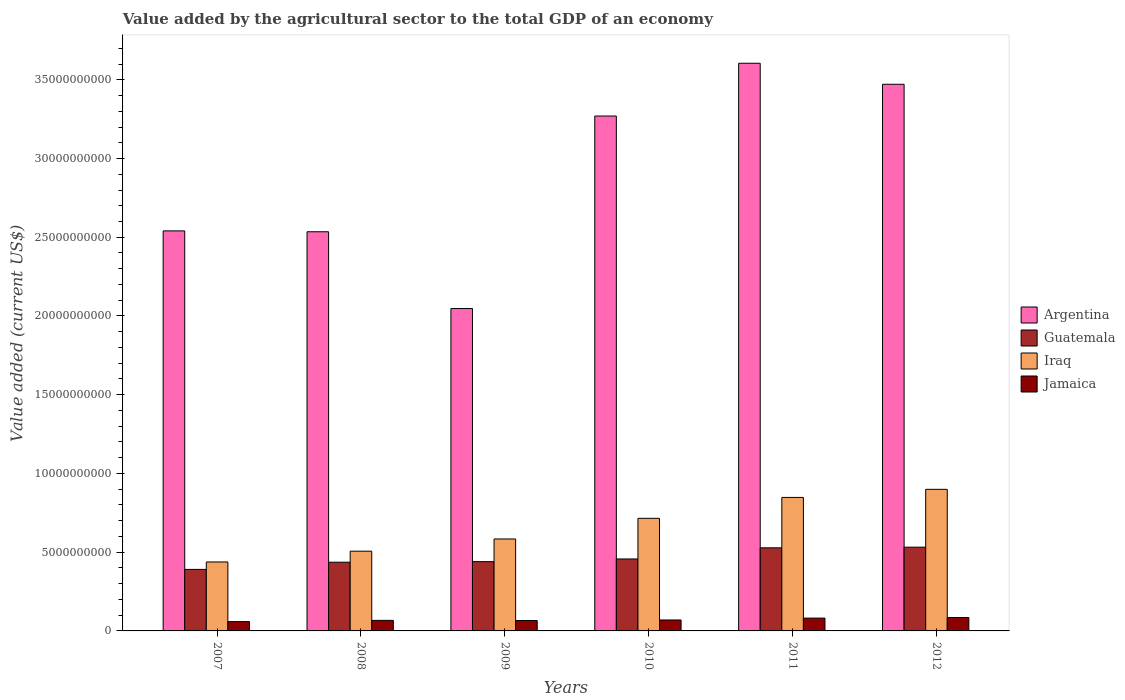How many different coloured bars are there?
Give a very brief answer. 4. How many groups of bars are there?
Give a very brief answer. 6. Are the number of bars on each tick of the X-axis equal?
Keep it short and to the point. Yes. How many bars are there on the 2nd tick from the right?
Your answer should be compact. 4. What is the label of the 5th group of bars from the left?
Ensure brevity in your answer.  2011. What is the value added by the agricultural sector to the total GDP in Iraq in 2008?
Offer a very short reply. 5.06e+09. Across all years, what is the maximum value added by the agricultural sector to the total GDP in Argentina?
Provide a short and direct response. 3.60e+1. Across all years, what is the minimum value added by the agricultural sector to the total GDP in Iraq?
Offer a very short reply. 4.38e+09. In which year was the value added by the agricultural sector to the total GDP in Argentina maximum?
Your response must be concise. 2011. In which year was the value added by the agricultural sector to the total GDP in Iraq minimum?
Your answer should be very brief. 2007. What is the total value added by the agricultural sector to the total GDP in Argentina in the graph?
Offer a terse response. 1.75e+11. What is the difference between the value added by the agricultural sector to the total GDP in Argentina in 2009 and that in 2010?
Your answer should be compact. -1.22e+1. What is the difference between the value added by the agricultural sector to the total GDP in Argentina in 2008 and the value added by the agricultural sector to the total GDP in Iraq in 2007?
Your response must be concise. 2.10e+1. What is the average value added by the agricultural sector to the total GDP in Argentina per year?
Keep it short and to the point. 2.91e+1. In the year 2012, what is the difference between the value added by the agricultural sector to the total GDP in Jamaica and value added by the agricultural sector to the total GDP in Iraq?
Make the answer very short. -8.14e+09. What is the ratio of the value added by the agricultural sector to the total GDP in Iraq in 2008 to that in 2012?
Ensure brevity in your answer.  0.56. What is the difference between the highest and the second highest value added by the agricultural sector to the total GDP in Argentina?
Your answer should be very brief. 1.33e+09. What is the difference between the highest and the lowest value added by the agricultural sector to the total GDP in Jamaica?
Give a very brief answer. 2.60e+08. In how many years, is the value added by the agricultural sector to the total GDP in Jamaica greater than the average value added by the agricultural sector to the total GDP in Jamaica taken over all years?
Ensure brevity in your answer.  2. Is the sum of the value added by the agricultural sector to the total GDP in Argentina in 2009 and 2011 greater than the maximum value added by the agricultural sector to the total GDP in Guatemala across all years?
Make the answer very short. Yes. What does the 2nd bar from the left in 2012 represents?
Offer a terse response. Guatemala. What does the 1st bar from the right in 2009 represents?
Give a very brief answer. Jamaica. Are all the bars in the graph horizontal?
Provide a short and direct response. No. What is the difference between two consecutive major ticks on the Y-axis?
Provide a short and direct response. 5.00e+09. Are the values on the major ticks of Y-axis written in scientific E-notation?
Give a very brief answer. No. Does the graph contain any zero values?
Your answer should be compact. No. Does the graph contain grids?
Ensure brevity in your answer.  No. Where does the legend appear in the graph?
Keep it short and to the point. Center right. What is the title of the graph?
Ensure brevity in your answer.  Value added by the agricultural sector to the total GDP of an economy. Does "Somalia" appear as one of the legend labels in the graph?
Keep it short and to the point. No. What is the label or title of the X-axis?
Offer a terse response. Years. What is the label or title of the Y-axis?
Your answer should be compact. Value added (current US$). What is the Value added (current US$) in Argentina in 2007?
Your response must be concise. 2.54e+1. What is the Value added (current US$) in Guatemala in 2007?
Provide a short and direct response. 3.91e+09. What is the Value added (current US$) in Iraq in 2007?
Your answer should be very brief. 4.38e+09. What is the Value added (current US$) in Jamaica in 2007?
Keep it short and to the point. 5.92e+08. What is the Value added (current US$) of Argentina in 2008?
Give a very brief answer. 2.53e+1. What is the Value added (current US$) of Guatemala in 2008?
Offer a terse response. 4.36e+09. What is the Value added (current US$) in Iraq in 2008?
Provide a succinct answer. 5.06e+09. What is the Value added (current US$) of Jamaica in 2008?
Your answer should be compact. 6.70e+08. What is the Value added (current US$) of Argentina in 2009?
Offer a terse response. 2.05e+1. What is the Value added (current US$) of Guatemala in 2009?
Provide a short and direct response. 4.40e+09. What is the Value added (current US$) of Iraq in 2009?
Your answer should be compact. 5.84e+09. What is the Value added (current US$) of Jamaica in 2009?
Provide a succinct answer. 6.59e+08. What is the Value added (current US$) in Argentina in 2010?
Offer a terse response. 3.27e+1. What is the Value added (current US$) of Guatemala in 2010?
Ensure brevity in your answer.  4.57e+09. What is the Value added (current US$) of Iraq in 2010?
Your answer should be compact. 7.15e+09. What is the Value added (current US$) of Jamaica in 2010?
Your response must be concise. 6.95e+08. What is the Value added (current US$) of Argentina in 2011?
Keep it short and to the point. 3.60e+1. What is the Value added (current US$) in Guatemala in 2011?
Make the answer very short. 5.28e+09. What is the Value added (current US$) of Iraq in 2011?
Provide a short and direct response. 8.48e+09. What is the Value added (current US$) in Jamaica in 2011?
Offer a terse response. 8.14e+08. What is the Value added (current US$) of Argentina in 2012?
Ensure brevity in your answer.  3.47e+1. What is the Value added (current US$) of Guatemala in 2012?
Your answer should be compact. 5.32e+09. What is the Value added (current US$) of Iraq in 2012?
Ensure brevity in your answer.  8.99e+09. What is the Value added (current US$) in Jamaica in 2012?
Offer a very short reply. 8.53e+08. Across all years, what is the maximum Value added (current US$) of Argentina?
Your answer should be compact. 3.60e+1. Across all years, what is the maximum Value added (current US$) of Guatemala?
Your answer should be compact. 5.32e+09. Across all years, what is the maximum Value added (current US$) in Iraq?
Make the answer very short. 8.99e+09. Across all years, what is the maximum Value added (current US$) in Jamaica?
Give a very brief answer. 8.53e+08. Across all years, what is the minimum Value added (current US$) of Argentina?
Provide a succinct answer. 2.05e+1. Across all years, what is the minimum Value added (current US$) of Guatemala?
Offer a very short reply. 3.91e+09. Across all years, what is the minimum Value added (current US$) of Iraq?
Provide a short and direct response. 4.38e+09. Across all years, what is the minimum Value added (current US$) in Jamaica?
Make the answer very short. 5.92e+08. What is the total Value added (current US$) of Argentina in the graph?
Your response must be concise. 1.75e+11. What is the total Value added (current US$) in Guatemala in the graph?
Your answer should be very brief. 2.78e+1. What is the total Value added (current US$) of Iraq in the graph?
Keep it short and to the point. 3.99e+1. What is the total Value added (current US$) of Jamaica in the graph?
Ensure brevity in your answer.  4.28e+09. What is the difference between the Value added (current US$) in Argentina in 2007 and that in 2008?
Give a very brief answer. 5.56e+07. What is the difference between the Value added (current US$) in Guatemala in 2007 and that in 2008?
Your answer should be very brief. -4.57e+08. What is the difference between the Value added (current US$) in Iraq in 2007 and that in 2008?
Offer a very short reply. -6.85e+08. What is the difference between the Value added (current US$) in Jamaica in 2007 and that in 2008?
Your answer should be compact. -7.80e+07. What is the difference between the Value added (current US$) in Argentina in 2007 and that in 2009?
Your answer should be very brief. 4.93e+09. What is the difference between the Value added (current US$) of Guatemala in 2007 and that in 2009?
Provide a short and direct response. -4.92e+08. What is the difference between the Value added (current US$) of Iraq in 2007 and that in 2009?
Your answer should be compact. -1.46e+09. What is the difference between the Value added (current US$) in Jamaica in 2007 and that in 2009?
Your response must be concise. -6.66e+07. What is the difference between the Value added (current US$) of Argentina in 2007 and that in 2010?
Your answer should be very brief. -7.29e+09. What is the difference between the Value added (current US$) of Guatemala in 2007 and that in 2010?
Your answer should be very brief. -6.63e+08. What is the difference between the Value added (current US$) in Iraq in 2007 and that in 2010?
Offer a very short reply. -2.77e+09. What is the difference between the Value added (current US$) of Jamaica in 2007 and that in 2010?
Your answer should be very brief. -1.03e+08. What is the difference between the Value added (current US$) of Argentina in 2007 and that in 2011?
Ensure brevity in your answer.  -1.06e+1. What is the difference between the Value added (current US$) in Guatemala in 2007 and that in 2011?
Offer a very short reply. -1.37e+09. What is the difference between the Value added (current US$) of Iraq in 2007 and that in 2011?
Your response must be concise. -4.10e+09. What is the difference between the Value added (current US$) of Jamaica in 2007 and that in 2011?
Your response must be concise. -2.22e+08. What is the difference between the Value added (current US$) of Argentina in 2007 and that in 2012?
Your answer should be compact. -9.31e+09. What is the difference between the Value added (current US$) of Guatemala in 2007 and that in 2012?
Offer a terse response. -1.41e+09. What is the difference between the Value added (current US$) of Iraq in 2007 and that in 2012?
Your answer should be very brief. -4.61e+09. What is the difference between the Value added (current US$) of Jamaica in 2007 and that in 2012?
Provide a succinct answer. -2.60e+08. What is the difference between the Value added (current US$) of Argentina in 2008 and that in 2009?
Your response must be concise. 4.88e+09. What is the difference between the Value added (current US$) in Guatemala in 2008 and that in 2009?
Offer a terse response. -3.50e+07. What is the difference between the Value added (current US$) in Iraq in 2008 and that in 2009?
Make the answer very short. -7.76e+08. What is the difference between the Value added (current US$) of Jamaica in 2008 and that in 2009?
Offer a terse response. 1.13e+07. What is the difference between the Value added (current US$) of Argentina in 2008 and that in 2010?
Offer a terse response. -7.35e+09. What is the difference between the Value added (current US$) in Guatemala in 2008 and that in 2010?
Your answer should be very brief. -2.06e+08. What is the difference between the Value added (current US$) of Iraq in 2008 and that in 2010?
Ensure brevity in your answer.  -2.09e+09. What is the difference between the Value added (current US$) of Jamaica in 2008 and that in 2010?
Provide a succinct answer. -2.50e+07. What is the difference between the Value added (current US$) in Argentina in 2008 and that in 2011?
Provide a succinct answer. -1.07e+1. What is the difference between the Value added (current US$) in Guatemala in 2008 and that in 2011?
Give a very brief answer. -9.14e+08. What is the difference between the Value added (current US$) of Iraq in 2008 and that in 2011?
Provide a succinct answer. -3.41e+09. What is the difference between the Value added (current US$) of Jamaica in 2008 and that in 2011?
Your answer should be compact. -1.44e+08. What is the difference between the Value added (current US$) of Argentina in 2008 and that in 2012?
Keep it short and to the point. -9.37e+09. What is the difference between the Value added (current US$) of Guatemala in 2008 and that in 2012?
Offer a very short reply. -9.54e+08. What is the difference between the Value added (current US$) of Iraq in 2008 and that in 2012?
Offer a very short reply. -3.93e+09. What is the difference between the Value added (current US$) of Jamaica in 2008 and that in 2012?
Make the answer very short. -1.82e+08. What is the difference between the Value added (current US$) in Argentina in 2009 and that in 2010?
Your response must be concise. -1.22e+1. What is the difference between the Value added (current US$) of Guatemala in 2009 and that in 2010?
Make the answer very short. -1.71e+08. What is the difference between the Value added (current US$) of Iraq in 2009 and that in 2010?
Keep it short and to the point. -1.31e+09. What is the difference between the Value added (current US$) in Jamaica in 2009 and that in 2010?
Ensure brevity in your answer.  -3.63e+07. What is the difference between the Value added (current US$) in Argentina in 2009 and that in 2011?
Your answer should be compact. -1.56e+1. What is the difference between the Value added (current US$) of Guatemala in 2009 and that in 2011?
Give a very brief answer. -8.79e+08. What is the difference between the Value added (current US$) in Iraq in 2009 and that in 2011?
Make the answer very short. -2.64e+09. What is the difference between the Value added (current US$) of Jamaica in 2009 and that in 2011?
Give a very brief answer. -1.55e+08. What is the difference between the Value added (current US$) in Argentina in 2009 and that in 2012?
Give a very brief answer. -1.42e+1. What is the difference between the Value added (current US$) of Guatemala in 2009 and that in 2012?
Your answer should be compact. -9.19e+08. What is the difference between the Value added (current US$) in Iraq in 2009 and that in 2012?
Offer a very short reply. -3.15e+09. What is the difference between the Value added (current US$) in Jamaica in 2009 and that in 2012?
Give a very brief answer. -1.94e+08. What is the difference between the Value added (current US$) of Argentina in 2010 and that in 2011?
Offer a terse response. -3.35e+09. What is the difference between the Value added (current US$) of Guatemala in 2010 and that in 2011?
Offer a terse response. -7.08e+08. What is the difference between the Value added (current US$) in Iraq in 2010 and that in 2011?
Provide a short and direct response. -1.33e+09. What is the difference between the Value added (current US$) of Jamaica in 2010 and that in 2011?
Your response must be concise. -1.19e+08. What is the difference between the Value added (current US$) of Argentina in 2010 and that in 2012?
Offer a very short reply. -2.02e+09. What is the difference between the Value added (current US$) in Guatemala in 2010 and that in 2012?
Your response must be concise. -7.48e+08. What is the difference between the Value added (current US$) of Iraq in 2010 and that in 2012?
Provide a short and direct response. -1.84e+09. What is the difference between the Value added (current US$) of Jamaica in 2010 and that in 2012?
Give a very brief answer. -1.57e+08. What is the difference between the Value added (current US$) in Argentina in 2011 and that in 2012?
Offer a very short reply. 1.33e+09. What is the difference between the Value added (current US$) in Guatemala in 2011 and that in 2012?
Provide a succinct answer. -4.02e+07. What is the difference between the Value added (current US$) of Iraq in 2011 and that in 2012?
Your response must be concise. -5.14e+08. What is the difference between the Value added (current US$) in Jamaica in 2011 and that in 2012?
Offer a very short reply. -3.84e+07. What is the difference between the Value added (current US$) of Argentina in 2007 and the Value added (current US$) of Guatemala in 2008?
Offer a very short reply. 2.10e+1. What is the difference between the Value added (current US$) of Argentina in 2007 and the Value added (current US$) of Iraq in 2008?
Keep it short and to the point. 2.03e+1. What is the difference between the Value added (current US$) of Argentina in 2007 and the Value added (current US$) of Jamaica in 2008?
Provide a short and direct response. 2.47e+1. What is the difference between the Value added (current US$) in Guatemala in 2007 and the Value added (current US$) in Iraq in 2008?
Offer a terse response. -1.16e+09. What is the difference between the Value added (current US$) in Guatemala in 2007 and the Value added (current US$) in Jamaica in 2008?
Keep it short and to the point. 3.24e+09. What is the difference between the Value added (current US$) in Iraq in 2007 and the Value added (current US$) in Jamaica in 2008?
Offer a terse response. 3.71e+09. What is the difference between the Value added (current US$) in Argentina in 2007 and the Value added (current US$) in Guatemala in 2009?
Your answer should be compact. 2.10e+1. What is the difference between the Value added (current US$) of Argentina in 2007 and the Value added (current US$) of Iraq in 2009?
Offer a terse response. 1.96e+1. What is the difference between the Value added (current US$) of Argentina in 2007 and the Value added (current US$) of Jamaica in 2009?
Give a very brief answer. 2.47e+1. What is the difference between the Value added (current US$) in Guatemala in 2007 and the Value added (current US$) in Iraq in 2009?
Give a very brief answer. -1.93e+09. What is the difference between the Value added (current US$) of Guatemala in 2007 and the Value added (current US$) of Jamaica in 2009?
Your answer should be very brief. 3.25e+09. What is the difference between the Value added (current US$) of Iraq in 2007 and the Value added (current US$) of Jamaica in 2009?
Offer a terse response. 3.72e+09. What is the difference between the Value added (current US$) in Argentina in 2007 and the Value added (current US$) in Guatemala in 2010?
Your response must be concise. 2.08e+1. What is the difference between the Value added (current US$) in Argentina in 2007 and the Value added (current US$) in Iraq in 2010?
Your answer should be very brief. 1.83e+1. What is the difference between the Value added (current US$) of Argentina in 2007 and the Value added (current US$) of Jamaica in 2010?
Ensure brevity in your answer.  2.47e+1. What is the difference between the Value added (current US$) of Guatemala in 2007 and the Value added (current US$) of Iraq in 2010?
Make the answer very short. -3.24e+09. What is the difference between the Value added (current US$) in Guatemala in 2007 and the Value added (current US$) in Jamaica in 2010?
Your answer should be compact. 3.21e+09. What is the difference between the Value added (current US$) in Iraq in 2007 and the Value added (current US$) in Jamaica in 2010?
Your answer should be compact. 3.68e+09. What is the difference between the Value added (current US$) in Argentina in 2007 and the Value added (current US$) in Guatemala in 2011?
Make the answer very short. 2.01e+1. What is the difference between the Value added (current US$) of Argentina in 2007 and the Value added (current US$) of Iraq in 2011?
Your answer should be compact. 1.69e+1. What is the difference between the Value added (current US$) in Argentina in 2007 and the Value added (current US$) in Jamaica in 2011?
Make the answer very short. 2.46e+1. What is the difference between the Value added (current US$) of Guatemala in 2007 and the Value added (current US$) of Iraq in 2011?
Offer a terse response. -4.57e+09. What is the difference between the Value added (current US$) in Guatemala in 2007 and the Value added (current US$) in Jamaica in 2011?
Make the answer very short. 3.09e+09. What is the difference between the Value added (current US$) in Iraq in 2007 and the Value added (current US$) in Jamaica in 2011?
Provide a short and direct response. 3.57e+09. What is the difference between the Value added (current US$) in Argentina in 2007 and the Value added (current US$) in Guatemala in 2012?
Provide a short and direct response. 2.01e+1. What is the difference between the Value added (current US$) of Argentina in 2007 and the Value added (current US$) of Iraq in 2012?
Offer a terse response. 1.64e+1. What is the difference between the Value added (current US$) of Argentina in 2007 and the Value added (current US$) of Jamaica in 2012?
Make the answer very short. 2.46e+1. What is the difference between the Value added (current US$) in Guatemala in 2007 and the Value added (current US$) in Iraq in 2012?
Provide a succinct answer. -5.08e+09. What is the difference between the Value added (current US$) of Guatemala in 2007 and the Value added (current US$) of Jamaica in 2012?
Keep it short and to the point. 3.05e+09. What is the difference between the Value added (current US$) in Iraq in 2007 and the Value added (current US$) in Jamaica in 2012?
Ensure brevity in your answer.  3.53e+09. What is the difference between the Value added (current US$) in Argentina in 2008 and the Value added (current US$) in Guatemala in 2009?
Offer a terse response. 2.09e+1. What is the difference between the Value added (current US$) of Argentina in 2008 and the Value added (current US$) of Iraq in 2009?
Your answer should be very brief. 1.95e+1. What is the difference between the Value added (current US$) in Argentina in 2008 and the Value added (current US$) in Jamaica in 2009?
Provide a succinct answer. 2.47e+1. What is the difference between the Value added (current US$) of Guatemala in 2008 and the Value added (current US$) of Iraq in 2009?
Make the answer very short. -1.48e+09. What is the difference between the Value added (current US$) of Guatemala in 2008 and the Value added (current US$) of Jamaica in 2009?
Keep it short and to the point. 3.71e+09. What is the difference between the Value added (current US$) of Iraq in 2008 and the Value added (current US$) of Jamaica in 2009?
Give a very brief answer. 4.41e+09. What is the difference between the Value added (current US$) in Argentina in 2008 and the Value added (current US$) in Guatemala in 2010?
Your response must be concise. 2.08e+1. What is the difference between the Value added (current US$) in Argentina in 2008 and the Value added (current US$) in Iraq in 2010?
Your response must be concise. 1.82e+1. What is the difference between the Value added (current US$) of Argentina in 2008 and the Value added (current US$) of Jamaica in 2010?
Provide a succinct answer. 2.47e+1. What is the difference between the Value added (current US$) of Guatemala in 2008 and the Value added (current US$) of Iraq in 2010?
Your answer should be very brief. -2.79e+09. What is the difference between the Value added (current US$) of Guatemala in 2008 and the Value added (current US$) of Jamaica in 2010?
Offer a terse response. 3.67e+09. What is the difference between the Value added (current US$) of Iraq in 2008 and the Value added (current US$) of Jamaica in 2010?
Offer a very short reply. 4.37e+09. What is the difference between the Value added (current US$) in Argentina in 2008 and the Value added (current US$) in Guatemala in 2011?
Offer a very short reply. 2.01e+1. What is the difference between the Value added (current US$) in Argentina in 2008 and the Value added (current US$) in Iraq in 2011?
Provide a succinct answer. 1.69e+1. What is the difference between the Value added (current US$) in Argentina in 2008 and the Value added (current US$) in Jamaica in 2011?
Your answer should be compact. 2.45e+1. What is the difference between the Value added (current US$) in Guatemala in 2008 and the Value added (current US$) in Iraq in 2011?
Keep it short and to the point. -4.11e+09. What is the difference between the Value added (current US$) in Guatemala in 2008 and the Value added (current US$) in Jamaica in 2011?
Offer a terse response. 3.55e+09. What is the difference between the Value added (current US$) of Iraq in 2008 and the Value added (current US$) of Jamaica in 2011?
Keep it short and to the point. 4.25e+09. What is the difference between the Value added (current US$) of Argentina in 2008 and the Value added (current US$) of Guatemala in 2012?
Give a very brief answer. 2.00e+1. What is the difference between the Value added (current US$) of Argentina in 2008 and the Value added (current US$) of Iraq in 2012?
Ensure brevity in your answer.  1.64e+1. What is the difference between the Value added (current US$) of Argentina in 2008 and the Value added (current US$) of Jamaica in 2012?
Offer a very short reply. 2.45e+1. What is the difference between the Value added (current US$) in Guatemala in 2008 and the Value added (current US$) in Iraq in 2012?
Your answer should be very brief. -4.63e+09. What is the difference between the Value added (current US$) of Guatemala in 2008 and the Value added (current US$) of Jamaica in 2012?
Offer a very short reply. 3.51e+09. What is the difference between the Value added (current US$) in Iraq in 2008 and the Value added (current US$) in Jamaica in 2012?
Ensure brevity in your answer.  4.21e+09. What is the difference between the Value added (current US$) in Argentina in 2009 and the Value added (current US$) in Guatemala in 2010?
Your answer should be compact. 1.59e+1. What is the difference between the Value added (current US$) in Argentina in 2009 and the Value added (current US$) in Iraq in 2010?
Your answer should be very brief. 1.33e+1. What is the difference between the Value added (current US$) of Argentina in 2009 and the Value added (current US$) of Jamaica in 2010?
Provide a succinct answer. 1.98e+1. What is the difference between the Value added (current US$) of Guatemala in 2009 and the Value added (current US$) of Iraq in 2010?
Provide a succinct answer. -2.75e+09. What is the difference between the Value added (current US$) of Guatemala in 2009 and the Value added (current US$) of Jamaica in 2010?
Keep it short and to the point. 3.70e+09. What is the difference between the Value added (current US$) of Iraq in 2009 and the Value added (current US$) of Jamaica in 2010?
Your answer should be compact. 5.14e+09. What is the difference between the Value added (current US$) of Argentina in 2009 and the Value added (current US$) of Guatemala in 2011?
Provide a short and direct response. 1.52e+1. What is the difference between the Value added (current US$) of Argentina in 2009 and the Value added (current US$) of Iraq in 2011?
Keep it short and to the point. 1.20e+1. What is the difference between the Value added (current US$) of Argentina in 2009 and the Value added (current US$) of Jamaica in 2011?
Provide a succinct answer. 1.97e+1. What is the difference between the Value added (current US$) in Guatemala in 2009 and the Value added (current US$) in Iraq in 2011?
Your answer should be very brief. -4.08e+09. What is the difference between the Value added (current US$) in Guatemala in 2009 and the Value added (current US$) in Jamaica in 2011?
Your answer should be very brief. 3.58e+09. What is the difference between the Value added (current US$) in Iraq in 2009 and the Value added (current US$) in Jamaica in 2011?
Your response must be concise. 5.03e+09. What is the difference between the Value added (current US$) of Argentina in 2009 and the Value added (current US$) of Guatemala in 2012?
Your answer should be compact. 1.52e+1. What is the difference between the Value added (current US$) of Argentina in 2009 and the Value added (current US$) of Iraq in 2012?
Provide a short and direct response. 1.15e+1. What is the difference between the Value added (current US$) of Argentina in 2009 and the Value added (current US$) of Jamaica in 2012?
Offer a very short reply. 1.96e+1. What is the difference between the Value added (current US$) of Guatemala in 2009 and the Value added (current US$) of Iraq in 2012?
Ensure brevity in your answer.  -4.59e+09. What is the difference between the Value added (current US$) of Guatemala in 2009 and the Value added (current US$) of Jamaica in 2012?
Offer a terse response. 3.55e+09. What is the difference between the Value added (current US$) of Iraq in 2009 and the Value added (current US$) of Jamaica in 2012?
Your answer should be very brief. 4.99e+09. What is the difference between the Value added (current US$) in Argentina in 2010 and the Value added (current US$) in Guatemala in 2011?
Provide a short and direct response. 2.74e+1. What is the difference between the Value added (current US$) of Argentina in 2010 and the Value added (current US$) of Iraq in 2011?
Provide a succinct answer. 2.42e+1. What is the difference between the Value added (current US$) of Argentina in 2010 and the Value added (current US$) of Jamaica in 2011?
Give a very brief answer. 3.19e+1. What is the difference between the Value added (current US$) of Guatemala in 2010 and the Value added (current US$) of Iraq in 2011?
Provide a short and direct response. -3.91e+09. What is the difference between the Value added (current US$) in Guatemala in 2010 and the Value added (current US$) in Jamaica in 2011?
Give a very brief answer. 3.76e+09. What is the difference between the Value added (current US$) in Iraq in 2010 and the Value added (current US$) in Jamaica in 2011?
Your answer should be very brief. 6.34e+09. What is the difference between the Value added (current US$) in Argentina in 2010 and the Value added (current US$) in Guatemala in 2012?
Your answer should be very brief. 2.74e+1. What is the difference between the Value added (current US$) in Argentina in 2010 and the Value added (current US$) in Iraq in 2012?
Ensure brevity in your answer.  2.37e+1. What is the difference between the Value added (current US$) of Argentina in 2010 and the Value added (current US$) of Jamaica in 2012?
Keep it short and to the point. 3.18e+1. What is the difference between the Value added (current US$) of Guatemala in 2010 and the Value added (current US$) of Iraq in 2012?
Give a very brief answer. -4.42e+09. What is the difference between the Value added (current US$) of Guatemala in 2010 and the Value added (current US$) of Jamaica in 2012?
Your answer should be compact. 3.72e+09. What is the difference between the Value added (current US$) in Iraq in 2010 and the Value added (current US$) in Jamaica in 2012?
Give a very brief answer. 6.30e+09. What is the difference between the Value added (current US$) of Argentina in 2011 and the Value added (current US$) of Guatemala in 2012?
Your answer should be compact. 3.07e+1. What is the difference between the Value added (current US$) of Argentina in 2011 and the Value added (current US$) of Iraq in 2012?
Give a very brief answer. 2.71e+1. What is the difference between the Value added (current US$) in Argentina in 2011 and the Value added (current US$) in Jamaica in 2012?
Give a very brief answer. 3.52e+1. What is the difference between the Value added (current US$) of Guatemala in 2011 and the Value added (current US$) of Iraq in 2012?
Offer a terse response. -3.71e+09. What is the difference between the Value added (current US$) in Guatemala in 2011 and the Value added (current US$) in Jamaica in 2012?
Your answer should be compact. 4.43e+09. What is the difference between the Value added (current US$) of Iraq in 2011 and the Value added (current US$) of Jamaica in 2012?
Give a very brief answer. 7.62e+09. What is the average Value added (current US$) in Argentina per year?
Keep it short and to the point. 2.91e+1. What is the average Value added (current US$) of Guatemala per year?
Your answer should be very brief. 4.64e+09. What is the average Value added (current US$) of Iraq per year?
Provide a short and direct response. 6.65e+09. What is the average Value added (current US$) of Jamaica per year?
Offer a terse response. 7.14e+08. In the year 2007, what is the difference between the Value added (current US$) of Argentina and Value added (current US$) of Guatemala?
Make the answer very short. 2.15e+1. In the year 2007, what is the difference between the Value added (current US$) of Argentina and Value added (current US$) of Iraq?
Make the answer very short. 2.10e+1. In the year 2007, what is the difference between the Value added (current US$) of Argentina and Value added (current US$) of Jamaica?
Your answer should be compact. 2.48e+1. In the year 2007, what is the difference between the Value added (current US$) in Guatemala and Value added (current US$) in Iraq?
Give a very brief answer. -4.73e+08. In the year 2007, what is the difference between the Value added (current US$) of Guatemala and Value added (current US$) of Jamaica?
Ensure brevity in your answer.  3.31e+09. In the year 2007, what is the difference between the Value added (current US$) in Iraq and Value added (current US$) in Jamaica?
Offer a very short reply. 3.79e+09. In the year 2008, what is the difference between the Value added (current US$) in Argentina and Value added (current US$) in Guatemala?
Offer a terse response. 2.10e+1. In the year 2008, what is the difference between the Value added (current US$) of Argentina and Value added (current US$) of Iraq?
Your answer should be very brief. 2.03e+1. In the year 2008, what is the difference between the Value added (current US$) in Argentina and Value added (current US$) in Jamaica?
Your answer should be very brief. 2.47e+1. In the year 2008, what is the difference between the Value added (current US$) in Guatemala and Value added (current US$) in Iraq?
Your answer should be compact. -7.00e+08. In the year 2008, what is the difference between the Value added (current US$) of Guatemala and Value added (current US$) of Jamaica?
Ensure brevity in your answer.  3.69e+09. In the year 2008, what is the difference between the Value added (current US$) in Iraq and Value added (current US$) in Jamaica?
Make the answer very short. 4.39e+09. In the year 2009, what is the difference between the Value added (current US$) of Argentina and Value added (current US$) of Guatemala?
Give a very brief answer. 1.61e+1. In the year 2009, what is the difference between the Value added (current US$) of Argentina and Value added (current US$) of Iraq?
Provide a succinct answer. 1.46e+1. In the year 2009, what is the difference between the Value added (current US$) of Argentina and Value added (current US$) of Jamaica?
Ensure brevity in your answer.  1.98e+1. In the year 2009, what is the difference between the Value added (current US$) of Guatemala and Value added (current US$) of Iraq?
Your response must be concise. -1.44e+09. In the year 2009, what is the difference between the Value added (current US$) of Guatemala and Value added (current US$) of Jamaica?
Make the answer very short. 3.74e+09. In the year 2009, what is the difference between the Value added (current US$) of Iraq and Value added (current US$) of Jamaica?
Provide a succinct answer. 5.18e+09. In the year 2010, what is the difference between the Value added (current US$) in Argentina and Value added (current US$) in Guatemala?
Make the answer very short. 2.81e+1. In the year 2010, what is the difference between the Value added (current US$) of Argentina and Value added (current US$) of Iraq?
Your answer should be very brief. 2.55e+1. In the year 2010, what is the difference between the Value added (current US$) of Argentina and Value added (current US$) of Jamaica?
Your answer should be very brief. 3.20e+1. In the year 2010, what is the difference between the Value added (current US$) of Guatemala and Value added (current US$) of Iraq?
Your answer should be very brief. -2.58e+09. In the year 2010, what is the difference between the Value added (current US$) in Guatemala and Value added (current US$) in Jamaica?
Ensure brevity in your answer.  3.87e+09. In the year 2010, what is the difference between the Value added (current US$) in Iraq and Value added (current US$) in Jamaica?
Offer a terse response. 6.46e+09. In the year 2011, what is the difference between the Value added (current US$) of Argentina and Value added (current US$) of Guatemala?
Ensure brevity in your answer.  3.08e+1. In the year 2011, what is the difference between the Value added (current US$) in Argentina and Value added (current US$) in Iraq?
Make the answer very short. 2.76e+1. In the year 2011, what is the difference between the Value added (current US$) of Argentina and Value added (current US$) of Jamaica?
Keep it short and to the point. 3.52e+1. In the year 2011, what is the difference between the Value added (current US$) of Guatemala and Value added (current US$) of Iraq?
Your answer should be very brief. -3.20e+09. In the year 2011, what is the difference between the Value added (current US$) of Guatemala and Value added (current US$) of Jamaica?
Ensure brevity in your answer.  4.46e+09. In the year 2011, what is the difference between the Value added (current US$) of Iraq and Value added (current US$) of Jamaica?
Offer a terse response. 7.66e+09. In the year 2012, what is the difference between the Value added (current US$) in Argentina and Value added (current US$) in Guatemala?
Your response must be concise. 2.94e+1. In the year 2012, what is the difference between the Value added (current US$) of Argentina and Value added (current US$) of Iraq?
Give a very brief answer. 2.57e+1. In the year 2012, what is the difference between the Value added (current US$) in Argentina and Value added (current US$) in Jamaica?
Offer a terse response. 3.39e+1. In the year 2012, what is the difference between the Value added (current US$) in Guatemala and Value added (current US$) in Iraq?
Make the answer very short. -3.67e+09. In the year 2012, what is the difference between the Value added (current US$) of Guatemala and Value added (current US$) of Jamaica?
Make the answer very short. 4.47e+09. In the year 2012, what is the difference between the Value added (current US$) of Iraq and Value added (current US$) of Jamaica?
Offer a very short reply. 8.14e+09. What is the ratio of the Value added (current US$) of Argentina in 2007 to that in 2008?
Your answer should be compact. 1. What is the ratio of the Value added (current US$) of Guatemala in 2007 to that in 2008?
Keep it short and to the point. 0.9. What is the ratio of the Value added (current US$) of Iraq in 2007 to that in 2008?
Offer a terse response. 0.86. What is the ratio of the Value added (current US$) of Jamaica in 2007 to that in 2008?
Make the answer very short. 0.88. What is the ratio of the Value added (current US$) of Argentina in 2007 to that in 2009?
Give a very brief answer. 1.24. What is the ratio of the Value added (current US$) in Guatemala in 2007 to that in 2009?
Your answer should be compact. 0.89. What is the ratio of the Value added (current US$) in Iraq in 2007 to that in 2009?
Offer a terse response. 0.75. What is the ratio of the Value added (current US$) of Jamaica in 2007 to that in 2009?
Ensure brevity in your answer.  0.9. What is the ratio of the Value added (current US$) in Argentina in 2007 to that in 2010?
Make the answer very short. 0.78. What is the ratio of the Value added (current US$) in Guatemala in 2007 to that in 2010?
Your response must be concise. 0.85. What is the ratio of the Value added (current US$) of Iraq in 2007 to that in 2010?
Your response must be concise. 0.61. What is the ratio of the Value added (current US$) in Jamaica in 2007 to that in 2010?
Your answer should be very brief. 0.85. What is the ratio of the Value added (current US$) in Argentina in 2007 to that in 2011?
Ensure brevity in your answer.  0.7. What is the ratio of the Value added (current US$) in Guatemala in 2007 to that in 2011?
Offer a very short reply. 0.74. What is the ratio of the Value added (current US$) of Iraq in 2007 to that in 2011?
Offer a very short reply. 0.52. What is the ratio of the Value added (current US$) of Jamaica in 2007 to that in 2011?
Provide a short and direct response. 0.73. What is the ratio of the Value added (current US$) of Argentina in 2007 to that in 2012?
Ensure brevity in your answer.  0.73. What is the ratio of the Value added (current US$) in Guatemala in 2007 to that in 2012?
Keep it short and to the point. 0.73. What is the ratio of the Value added (current US$) in Iraq in 2007 to that in 2012?
Your answer should be very brief. 0.49. What is the ratio of the Value added (current US$) of Jamaica in 2007 to that in 2012?
Keep it short and to the point. 0.69. What is the ratio of the Value added (current US$) of Argentina in 2008 to that in 2009?
Provide a short and direct response. 1.24. What is the ratio of the Value added (current US$) in Guatemala in 2008 to that in 2009?
Provide a short and direct response. 0.99. What is the ratio of the Value added (current US$) of Iraq in 2008 to that in 2009?
Provide a succinct answer. 0.87. What is the ratio of the Value added (current US$) in Jamaica in 2008 to that in 2009?
Provide a succinct answer. 1.02. What is the ratio of the Value added (current US$) in Argentina in 2008 to that in 2010?
Your answer should be compact. 0.78. What is the ratio of the Value added (current US$) in Guatemala in 2008 to that in 2010?
Provide a succinct answer. 0.95. What is the ratio of the Value added (current US$) in Iraq in 2008 to that in 2010?
Your response must be concise. 0.71. What is the ratio of the Value added (current US$) of Jamaica in 2008 to that in 2010?
Your answer should be compact. 0.96. What is the ratio of the Value added (current US$) in Argentina in 2008 to that in 2011?
Your answer should be very brief. 0.7. What is the ratio of the Value added (current US$) of Guatemala in 2008 to that in 2011?
Offer a very short reply. 0.83. What is the ratio of the Value added (current US$) in Iraq in 2008 to that in 2011?
Your answer should be very brief. 0.6. What is the ratio of the Value added (current US$) of Jamaica in 2008 to that in 2011?
Keep it short and to the point. 0.82. What is the ratio of the Value added (current US$) of Argentina in 2008 to that in 2012?
Offer a terse response. 0.73. What is the ratio of the Value added (current US$) in Guatemala in 2008 to that in 2012?
Your response must be concise. 0.82. What is the ratio of the Value added (current US$) in Iraq in 2008 to that in 2012?
Ensure brevity in your answer.  0.56. What is the ratio of the Value added (current US$) of Jamaica in 2008 to that in 2012?
Provide a short and direct response. 0.79. What is the ratio of the Value added (current US$) of Argentina in 2009 to that in 2010?
Your answer should be compact. 0.63. What is the ratio of the Value added (current US$) in Guatemala in 2009 to that in 2010?
Give a very brief answer. 0.96. What is the ratio of the Value added (current US$) in Iraq in 2009 to that in 2010?
Keep it short and to the point. 0.82. What is the ratio of the Value added (current US$) of Jamaica in 2009 to that in 2010?
Provide a succinct answer. 0.95. What is the ratio of the Value added (current US$) in Argentina in 2009 to that in 2011?
Provide a short and direct response. 0.57. What is the ratio of the Value added (current US$) in Guatemala in 2009 to that in 2011?
Provide a short and direct response. 0.83. What is the ratio of the Value added (current US$) of Iraq in 2009 to that in 2011?
Offer a very short reply. 0.69. What is the ratio of the Value added (current US$) in Jamaica in 2009 to that in 2011?
Keep it short and to the point. 0.81. What is the ratio of the Value added (current US$) in Argentina in 2009 to that in 2012?
Provide a short and direct response. 0.59. What is the ratio of the Value added (current US$) of Guatemala in 2009 to that in 2012?
Provide a short and direct response. 0.83. What is the ratio of the Value added (current US$) in Iraq in 2009 to that in 2012?
Offer a very short reply. 0.65. What is the ratio of the Value added (current US$) in Jamaica in 2009 to that in 2012?
Give a very brief answer. 0.77. What is the ratio of the Value added (current US$) in Argentina in 2010 to that in 2011?
Give a very brief answer. 0.91. What is the ratio of the Value added (current US$) in Guatemala in 2010 to that in 2011?
Your answer should be compact. 0.87. What is the ratio of the Value added (current US$) in Iraq in 2010 to that in 2011?
Make the answer very short. 0.84. What is the ratio of the Value added (current US$) of Jamaica in 2010 to that in 2011?
Your answer should be compact. 0.85. What is the ratio of the Value added (current US$) in Argentina in 2010 to that in 2012?
Provide a short and direct response. 0.94. What is the ratio of the Value added (current US$) of Guatemala in 2010 to that in 2012?
Your answer should be compact. 0.86. What is the ratio of the Value added (current US$) of Iraq in 2010 to that in 2012?
Ensure brevity in your answer.  0.8. What is the ratio of the Value added (current US$) of Jamaica in 2010 to that in 2012?
Your response must be concise. 0.82. What is the ratio of the Value added (current US$) of Argentina in 2011 to that in 2012?
Your answer should be very brief. 1.04. What is the ratio of the Value added (current US$) of Guatemala in 2011 to that in 2012?
Provide a short and direct response. 0.99. What is the ratio of the Value added (current US$) of Iraq in 2011 to that in 2012?
Offer a very short reply. 0.94. What is the ratio of the Value added (current US$) in Jamaica in 2011 to that in 2012?
Keep it short and to the point. 0.95. What is the difference between the highest and the second highest Value added (current US$) of Argentina?
Ensure brevity in your answer.  1.33e+09. What is the difference between the highest and the second highest Value added (current US$) in Guatemala?
Your response must be concise. 4.02e+07. What is the difference between the highest and the second highest Value added (current US$) of Iraq?
Provide a short and direct response. 5.14e+08. What is the difference between the highest and the second highest Value added (current US$) in Jamaica?
Offer a very short reply. 3.84e+07. What is the difference between the highest and the lowest Value added (current US$) of Argentina?
Your answer should be very brief. 1.56e+1. What is the difference between the highest and the lowest Value added (current US$) of Guatemala?
Ensure brevity in your answer.  1.41e+09. What is the difference between the highest and the lowest Value added (current US$) of Iraq?
Keep it short and to the point. 4.61e+09. What is the difference between the highest and the lowest Value added (current US$) of Jamaica?
Offer a terse response. 2.60e+08. 